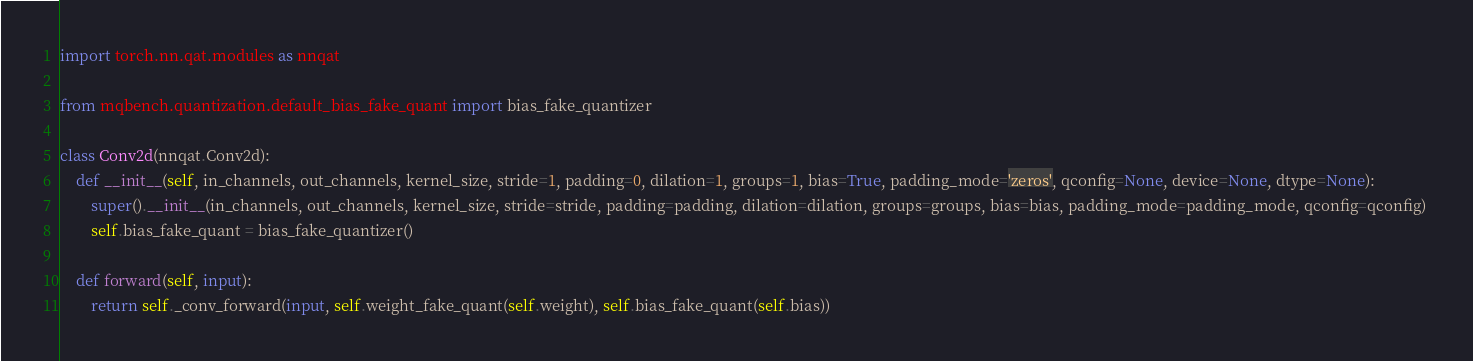Convert code to text. <code><loc_0><loc_0><loc_500><loc_500><_Python_>import torch.nn.qat.modules as nnqat

from mqbench.quantization.default_bias_fake_quant import bias_fake_quantizer

class Conv2d(nnqat.Conv2d):
    def __init__(self, in_channels, out_channels, kernel_size, stride=1, padding=0, dilation=1, groups=1, bias=True, padding_mode='zeros', qconfig=None, device=None, dtype=None):
        super().__init__(in_channels, out_channels, kernel_size, stride=stride, padding=padding, dilation=dilation, groups=groups, bias=bias, padding_mode=padding_mode, qconfig=qconfig) 
        self.bias_fake_quant = bias_fake_quantizer()

    def forward(self, input):
        return self._conv_forward(input, self.weight_fake_quant(self.weight), self.bias_fake_quant(self.bias)) 
</code> 